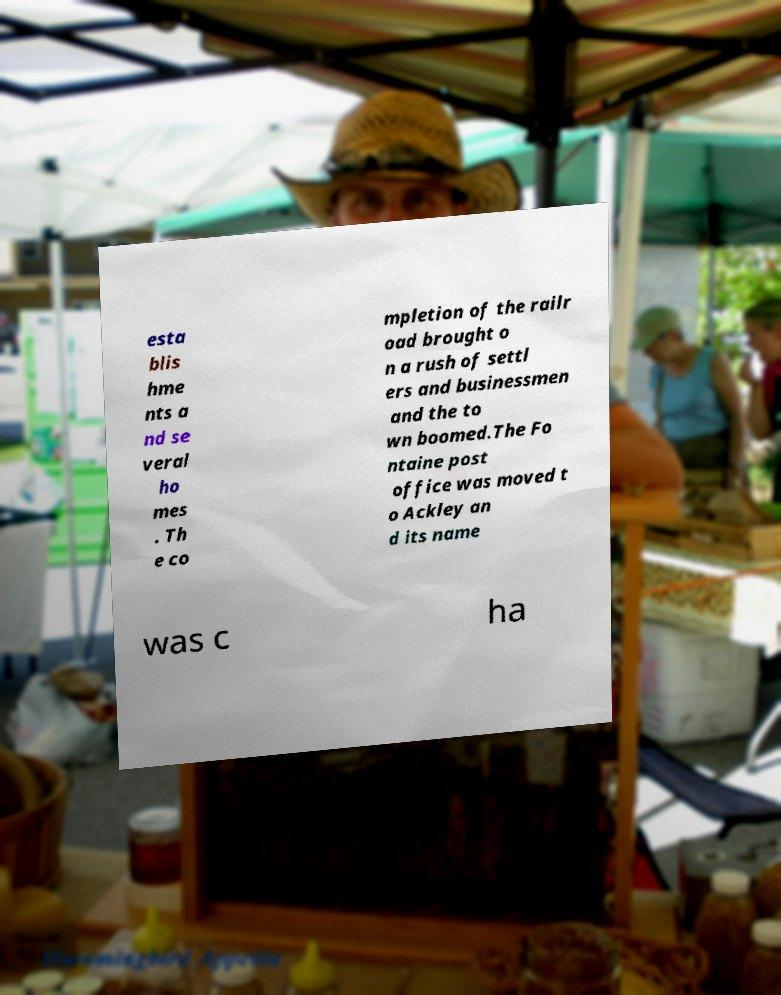I need the written content from this picture converted into text. Can you do that? esta blis hme nts a nd se veral ho mes . Th e co mpletion of the railr oad brought o n a rush of settl ers and businessmen and the to wn boomed.The Fo ntaine post office was moved t o Ackley an d its name was c ha 